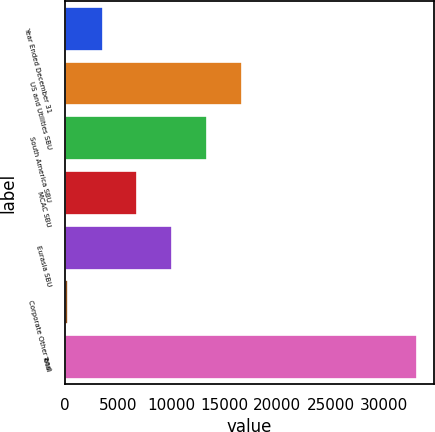<chart> <loc_0><loc_0><loc_500><loc_500><bar_chart><fcel>Year Ended December 31<fcel>US and Utilities SBU<fcel>South America SBU<fcel>MCAC SBU<fcel>Eurasia SBU<fcel>Corporate Other and<fcel>Total<nl><fcel>3547.9<fcel>16687.5<fcel>13402.6<fcel>6832.8<fcel>10117.7<fcel>263<fcel>33112<nl></chart> 